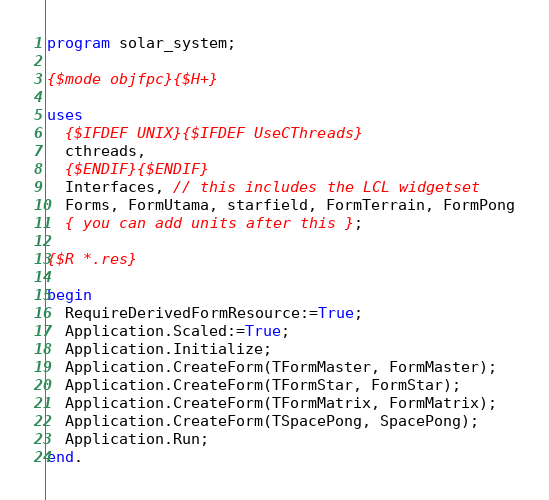<code> <loc_0><loc_0><loc_500><loc_500><_Pascal_>program solar_system;

{$mode objfpc}{$H+}

uses
  {$IFDEF UNIX}{$IFDEF UseCThreads}
  cthreads,
  {$ENDIF}{$ENDIF}
  Interfaces, // this includes the LCL widgetset
  Forms, FormUtama, starfield, FormTerrain, FormPong
  { you can add units after this };

{$R *.res}

begin
  RequireDerivedFormResource:=True;
  Application.Scaled:=True;
  Application.Initialize;
  Application.CreateForm(TFormMaster, FormMaster);
  Application.CreateForm(TFormStar, FormStar);
  Application.CreateForm(TFormMatrix, FormMatrix);
  Application.CreateForm(TSpacePong, SpacePong);
  Application.Run;
end.

</code> 